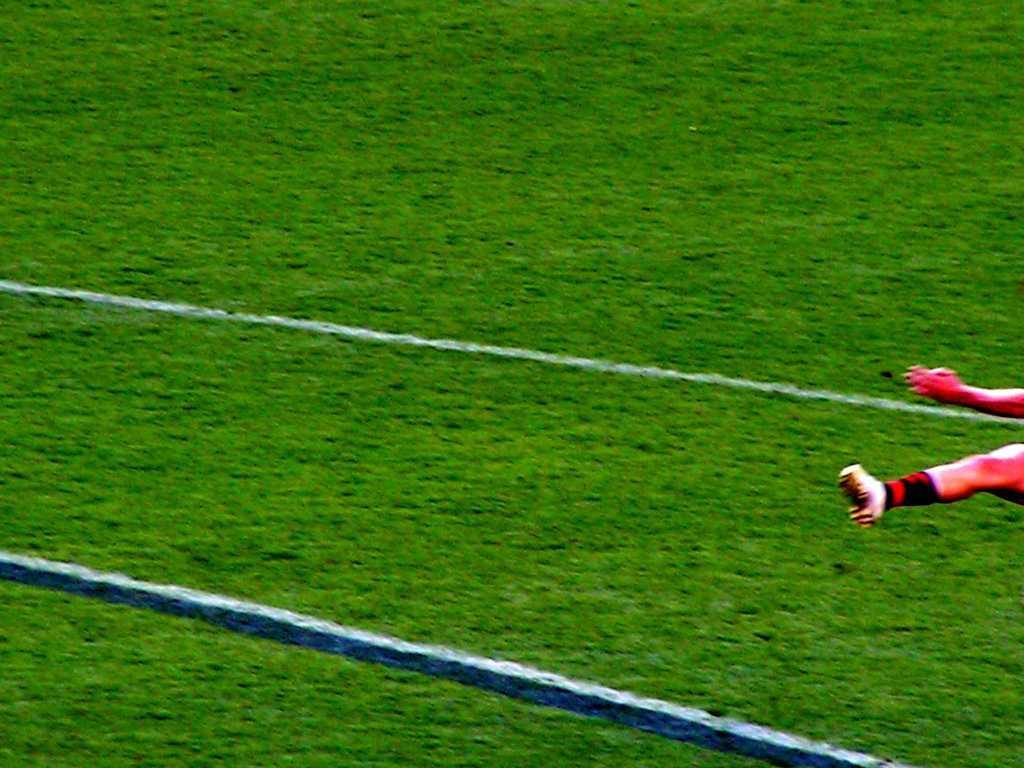Describe this image in one or two sentences. In this image we can see a ground with grass. On the right side we can see hand and leg of person. 